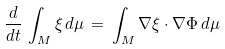<formula> <loc_0><loc_0><loc_500><loc_500>\frac { d } { d t } \, \int _ { M } \xi \, d \mu \, = \, \int _ { M } \nabla \xi \cdot \nabla \Phi \, d \mu</formula> 